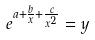<formula> <loc_0><loc_0><loc_500><loc_500>e ^ { a + \frac { b } { x } + \frac { c } { x ^ { 2 } } } = y</formula> 